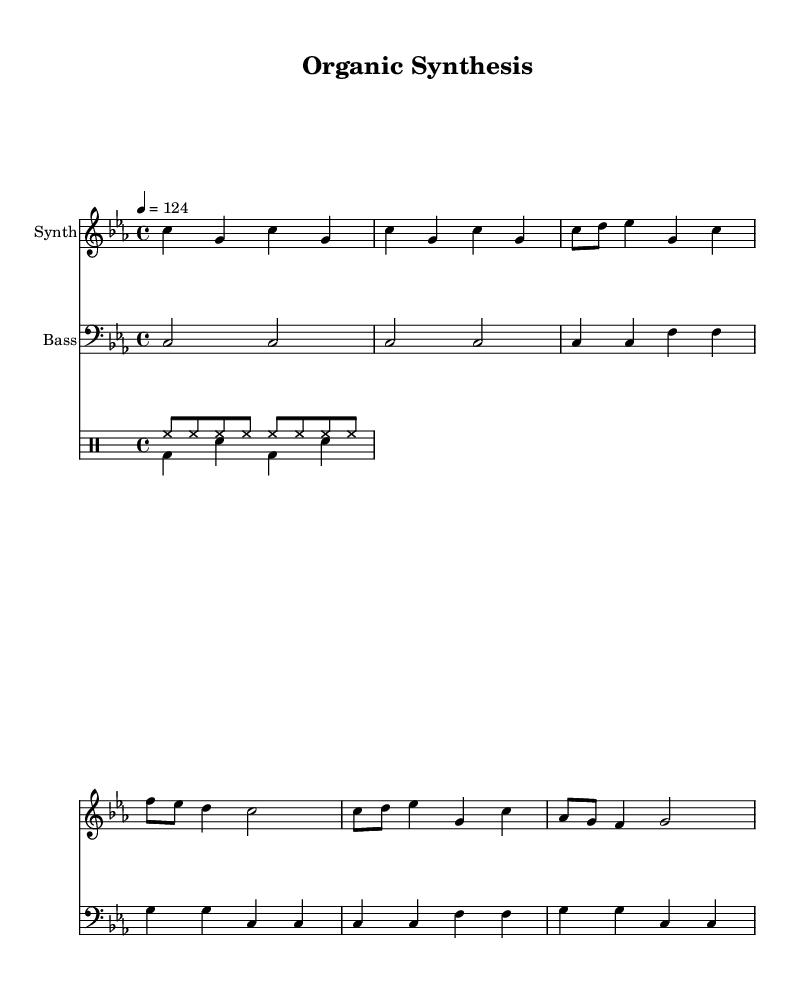What is the key signature of this music? The key signature indicated in the music sheet is the 'C' minor, as shown by the 'b flat' and 'e flat' notes in the staff.
Answer: C minor What is the time signature of this music? The time signature appears at the beginning of the music sheet, which is indicated as 4/4, meaning there are four beats in a measure and that the quarter note gets one beat.
Answer: 4/4 What is the tempo marking of this piece? The tempo marking specifies the beats per minute, which is notated as '4 = 124'. This means there are 124 beats in one minute.
Answer: 124 How many measures are there in the intro section? By observing the 'Intro' section, we can see there are two repeated measures consisting of two bars each, totaling four measures in the intro.
Answer: 4 What instruments are featured in this score? The score includes two main instruments: a synthesizer and a bass, along with a drum set that features hi-hat and kick/snare patterns.
Answer: Synthesizer, Bass, Drumset What pattern is used for the hi-hat in the drum section? The hi-hat pattern consists of eight notes that are evenly spaced indicating a steady rhythm, represented by 'hh' notations in the drum part.
Answer: Eight notes Why is the bass line composed of longer note values compared to the synthesizer? The bass line typically provides harmonic support and grounding for the synthesizer melody, which often plays shorter rhythmic figures contributing to the overall groove of house music.
Answer: Harmonic support 